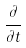<formula> <loc_0><loc_0><loc_500><loc_500>\frac { \partial } { \partial t }</formula> 